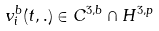<formula> <loc_0><loc_0><loc_500><loc_500>v ^ { b } _ { i } ( t , . ) \in C ^ { 3 , b } \cap H ^ { 3 , p }</formula> 